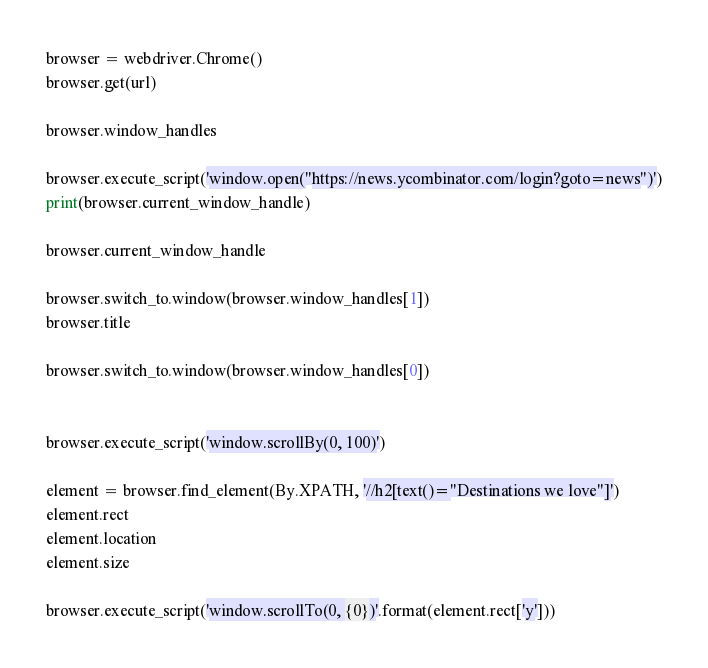Convert code to text. <code><loc_0><loc_0><loc_500><loc_500><_Python_>browser = webdriver.Chrome()
browser.get(url)

browser.window_handles

browser.execute_script('window.open("https://news.ycombinator.com/login?goto=news")')
print(browser.current_window_handle)

browser.current_window_handle

browser.switch_to.window(browser.window_handles[1])
browser.title

browser.switch_to.window(browser.window_handles[0])


browser.execute_script('window.scrollBy(0, 100)')

element = browser.find_element(By.XPATH, '//h2[text()="Destinations we love"]')
element.rect
element.location
element.size

browser.execute_script('window.scrollTo(0, {0})'.format(element.rect['y']))
</code> 